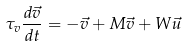<formula> <loc_0><loc_0><loc_500><loc_500>\tau _ { v } \frac { d \vec { v } } { d t } = - \vec { v } + M \vec { v } + W \vec { u }</formula> 